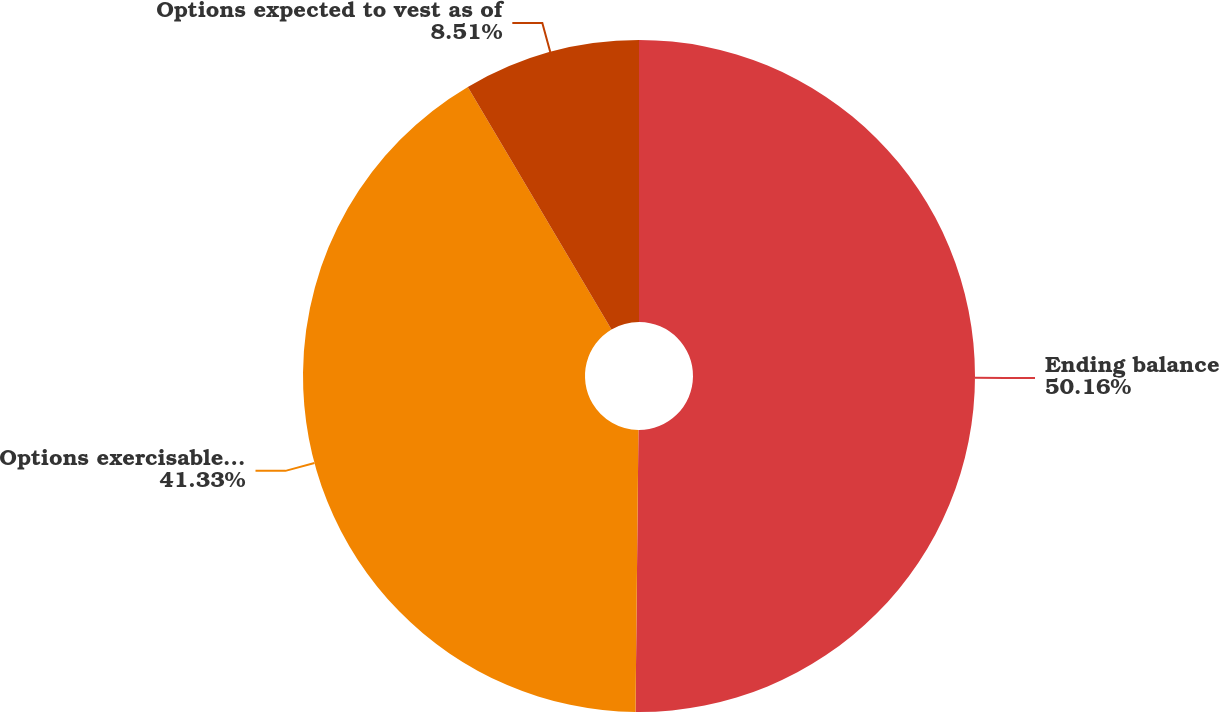<chart> <loc_0><loc_0><loc_500><loc_500><pie_chart><fcel>Ending balance<fcel>Options exercisable as of<fcel>Options expected to vest as of<nl><fcel>50.17%<fcel>41.33%<fcel>8.51%<nl></chart> 